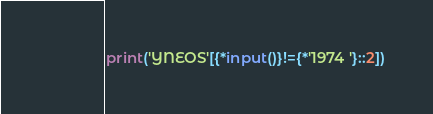<code> <loc_0><loc_0><loc_500><loc_500><_Cython_>print('YNEOS'[{*input()}!={*'1974 '}::2])</code> 